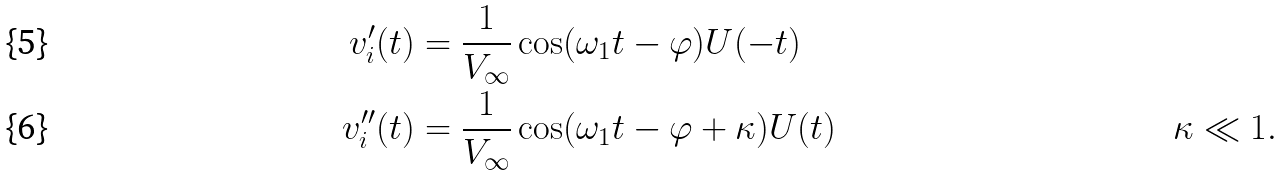Convert formula to latex. <formula><loc_0><loc_0><loc_500><loc_500>v ^ { \prime } _ { i } ( t ) & = \frac { 1 } { V _ { \infty } } \cos ( \omega _ { 1 } t - \varphi ) U ( - t ) \\ v ^ { \prime \prime } _ { i } ( t ) & = \frac { 1 } { V _ { \infty } } \cos ( \omega _ { 1 } t - \varphi + \kappa ) U ( t ) & \kappa \ll 1 .</formula> 